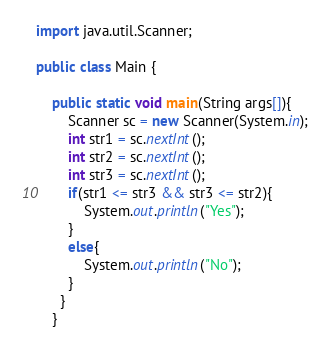Convert code to text. <code><loc_0><loc_0><loc_500><loc_500><_Java_>import java.util.Scanner;

public class Main {
	
	public static void main(String args[]){
		Scanner sc = new Scanner(System.in);
		int str1 = sc.nextInt();
		int str2 = sc.nextInt();
		int str3 = sc.nextInt();
		if(str1 <= str3 && str3 <= str2){
			System.out.println("Yes");
		}
		else{
			System.out.println("No");
		}
	  }
	}</code> 